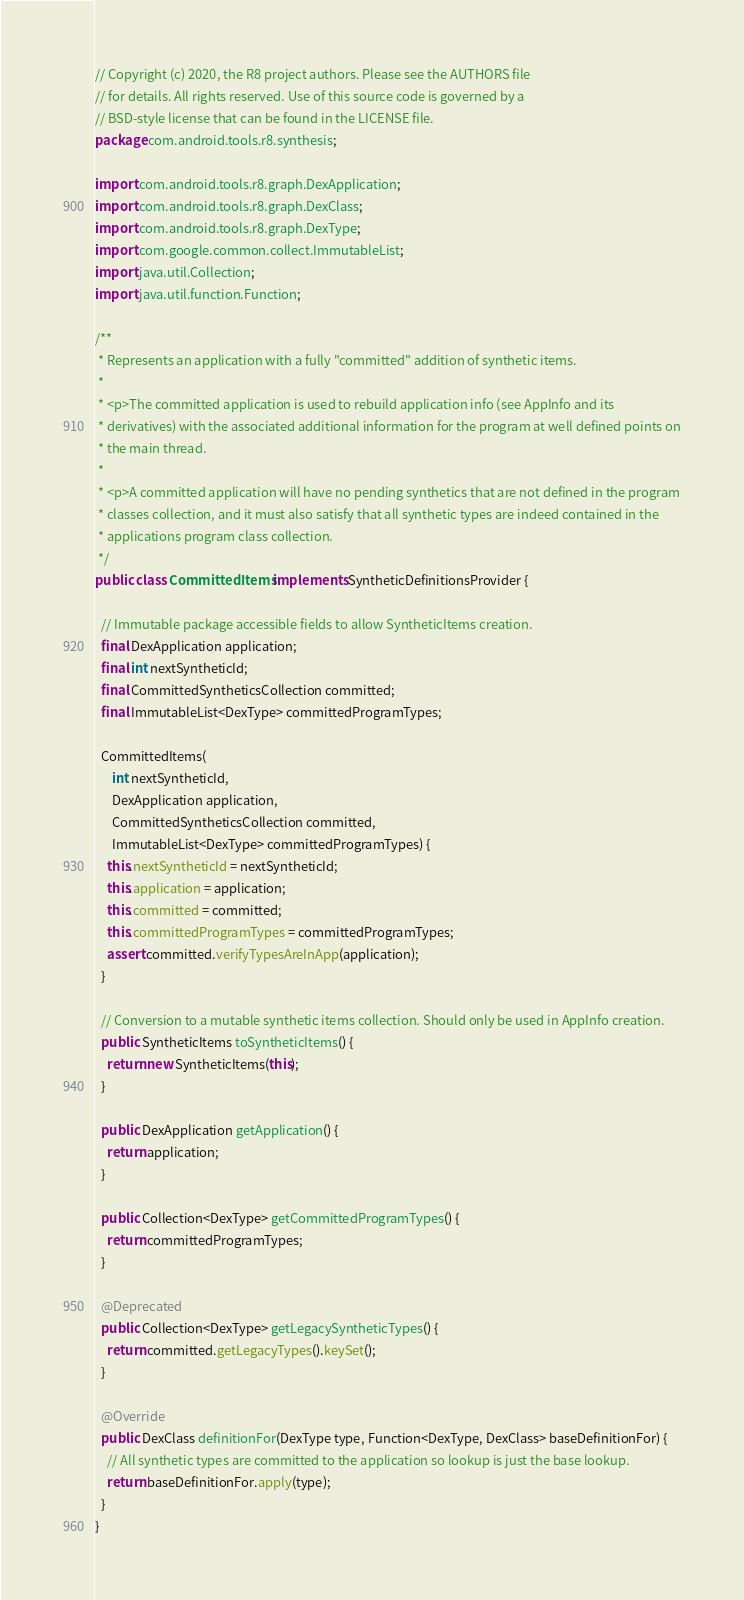<code> <loc_0><loc_0><loc_500><loc_500><_Java_>// Copyright (c) 2020, the R8 project authors. Please see the AUTHORS file
// for details. All rights reserved. Use of this source code is governed by a
// BSD-style license that can be found in the LICENSE file.
package com.android.tools.r8.synthesis;

import com.android.tools.r8.graph.DexApplication;
import com.android.tools.r8.graph.DexClass;
import com.android.tools.r8.graph.DexType;
import com.google.common.collect.ImmutableList;
import java.util.Collection;
import java.util.function.Function;

/**
 * Represents an application with a fully "committed" addition of synthetic items.
 *
 * <p>The committed application is used to rebuild application info (see AppInfo and its
 * derivatives) with the associated additional information for the program at well defined points on
 * the main thread.
 *
 * <p>A committed application will have no pending synthetics that are not defined in the program
 * classes collection, and it must also satisfy that all synthetic types are indeed contained in the
 * applications program class collection.
 */
public class CommittedItems implements SyntheticDefinitionsProvider {

  // Immutable package accessible fields to allow SyntheticItems creation.
  final DexApplication application;
  final int nextSyntheticId;
  final CommittedSyntheticsCollection committed;
  final ImmutableList<DexType> committedProgramTypes;

  CommittedItems(
      int nextSyntheticId,
      DexApplication application,
      CommittedSyntheticsCollection committed,
      ImmutableList<DexType> committedProgramTypes) {
    this.nextSyntheticId = nextSyntheticId;
    this.application = application;
    this.committed = committed;
    this.committedProgramTypes = committedProgramTypes;
    assert committed.verifyTypesAreInApp(application);
  }

  // Conversion to a mutable synthetic items collection. Should only be used in AppInfo creation.
  public SyntheticItems toSyntheticItems() {
    return new SyntheticItems(this);
  }

  public DexApplication getApplication() {
    return application;
  }

  public Collection<DexType> getCommittedProgramTypes() {
    return committedProgramTypes;
  }

  @Deprecated
  public Collection<DexType> getLegacySyntheticTypes() {
    return committed.getLegacyTypes().keySet();
  }

  @Override
  public DexClass definitionFor(DexType type, Function<DexType, DexClass> baseDefinitionFor) {
    // All synthetic types are committed to the application so lookup is just the base lookup.
    return baseDefinitionFor.apply(type);
  }
}
</code> 